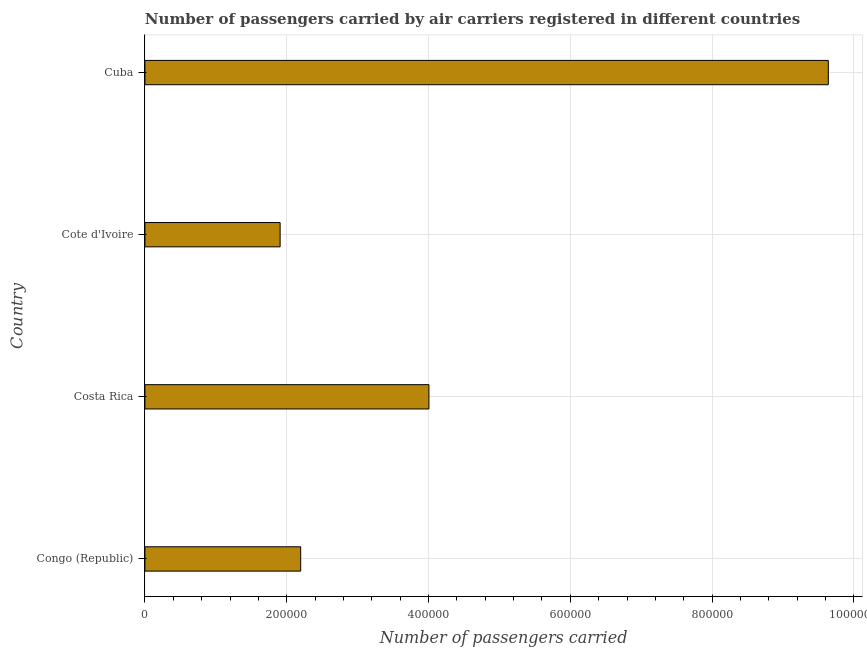Does the graph contain grids?
Ensure brevity in your answer.  Yes. What is the title of the graph?
Make the answer very short. Number of passengers carried by air carriers registered in different countries. What is the label or title of the X-axis?
Your answer should be compact. Number of passengers carried. What is the number of passengers carried in Congo (Republic)?
Provide a succinct answer. 2.20e+05. Across all countries, what is the maximum number of passengers carried?
Keep it short and to the point. 9.64e+05. Across all countries, what is the minimum number of passengers carried?
Ensure brevity in your answer.  1.91e+05. In which country was the number of passengers carried maximum?
Give a very brief answer. Cuba. In which country was the number of passengers carried minimum?
Provide a succinct answer. Cote d'Ivoire. What is the sum of the number of passengers carried?
Provide a short and direct response. 1.77e+06. What is the difference between the number of passengers carried in Costa Rica and Cuba?
Your response must be concise. -5.63e+05. What is the average number of passengers carried per country?
Give a very brief answer. 4.44e+05. What is the median number of passengers carried?
Provide a short and direct response. 3.10e+05. In how many countries, is the number of passengers carried greater than 640000 ?
Your answer should be very brief. 1. What is the ratio of the number of passengers carried in Congo (Republic) to that in Cuba?
Ensure brevity in your answer.  0.23. Is the difference between the number of passengers carried in Congo (Republic) and Cuba greater than the difference between any two countries?
Ensure brevity in your answer.  No. What is the difference between the highest and the second highest number of passengers carried?
Keep it short and to the point. 5.63e+05. What is the difference between the highest and the lowest number of passengers carried?
Your answer should be very brief. 7.73e+05. How many countries are there in the graph?
Ensure brevity in your answer.  4. What is the difference between two consecutive major ticks on the X-axis?
Offer a very short reply. 2.00e+05. What is the Number of passengers carried in Congo (Republic)?
Give a very brief answer. 2.20e+05. What is the Number of passengers carried of Costa Rica?
Provide a short and direct response. 4.01e+05. What is the Number of passengers carried in Cote d'Ivoire?
Your answer should be very brief. 1.91e+05. What is the Number of passengers carried of Cuba?
Your answer should be compact. 9.64e+05. What is the difference between the Number of passengers carried in Congo (Republic) and Costa Rica?
Ensure brevity in your answer.  -1.81e+05. What is the difference between the Number of passengers carried in Congo (Republic) and Cote d'Ivoire?
Your answer should be compact. 2.90e+04. What is the difference between the Number of passengers carried in Congo (Republic) and Cuba?
Provide a short and direct response. -7.44e+05. What is the difference between the Number of passengers carried in Costa Rica and Cote d'Ivoire?
Provide a short and direct response. 2.10e+05. What is the difference between the Number of passengers carried in Costa Rica and Cuba?
Make the answer very short. -5.63e+05. What is the difference between the Number of passengers carried in Cote d'Ivoire and Cuba?
Your response must be concise. -7.73e+05. What is the ratio of the Number of passengers carried in Congo (Republic) to that in Costa Rica?
Provide a succinct answer. 0.55. What is the ratio of the Number of passengers carried in Congo (Republic) to that in Cote d'Ivoire?
Your answer should be compact. 1.15. What is the ratio of the Number of passengers carried in Congo (Republic) to that in Cuba?
Make the answer very short. 0.23. What is the ratio of the Number of passengers carried in Costa Rica to that in Cote d'Ivoire?
Ensure brevity in your answer.  2.1. What is the ratio of the Number of passengers carried in Costa Rica to that in Cuba?
Keep it short and to the point. 0.42. What is the ratio of the Number of passengers carried in Cote d'Ivoire to that in Cuba?
Offer a terse response. 0.2. 